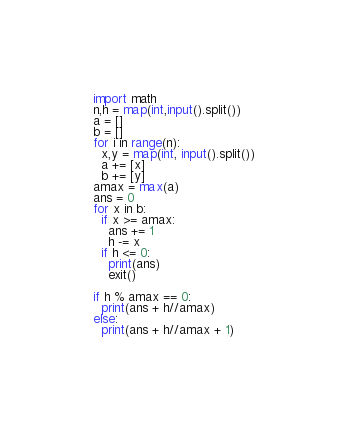<code> <loc_0><loc_0><loc_500><loc_500><_Python_>import math
n,h = map(int,input().split())
a = []
b = []
for i in range(n):
  x,y = map(int, input().split())
  a += [x]
  b += [y]
amax = max(a)
ans = 0
for x in b:
  if x >= amax:
    ans += 1
    h -= x
  if h <= 0:
    print(ans)
    exit()
 
if h % amax == 0:
  print(ans + h//amax)
else:
  print(ans + h//amax + 1)</code> 